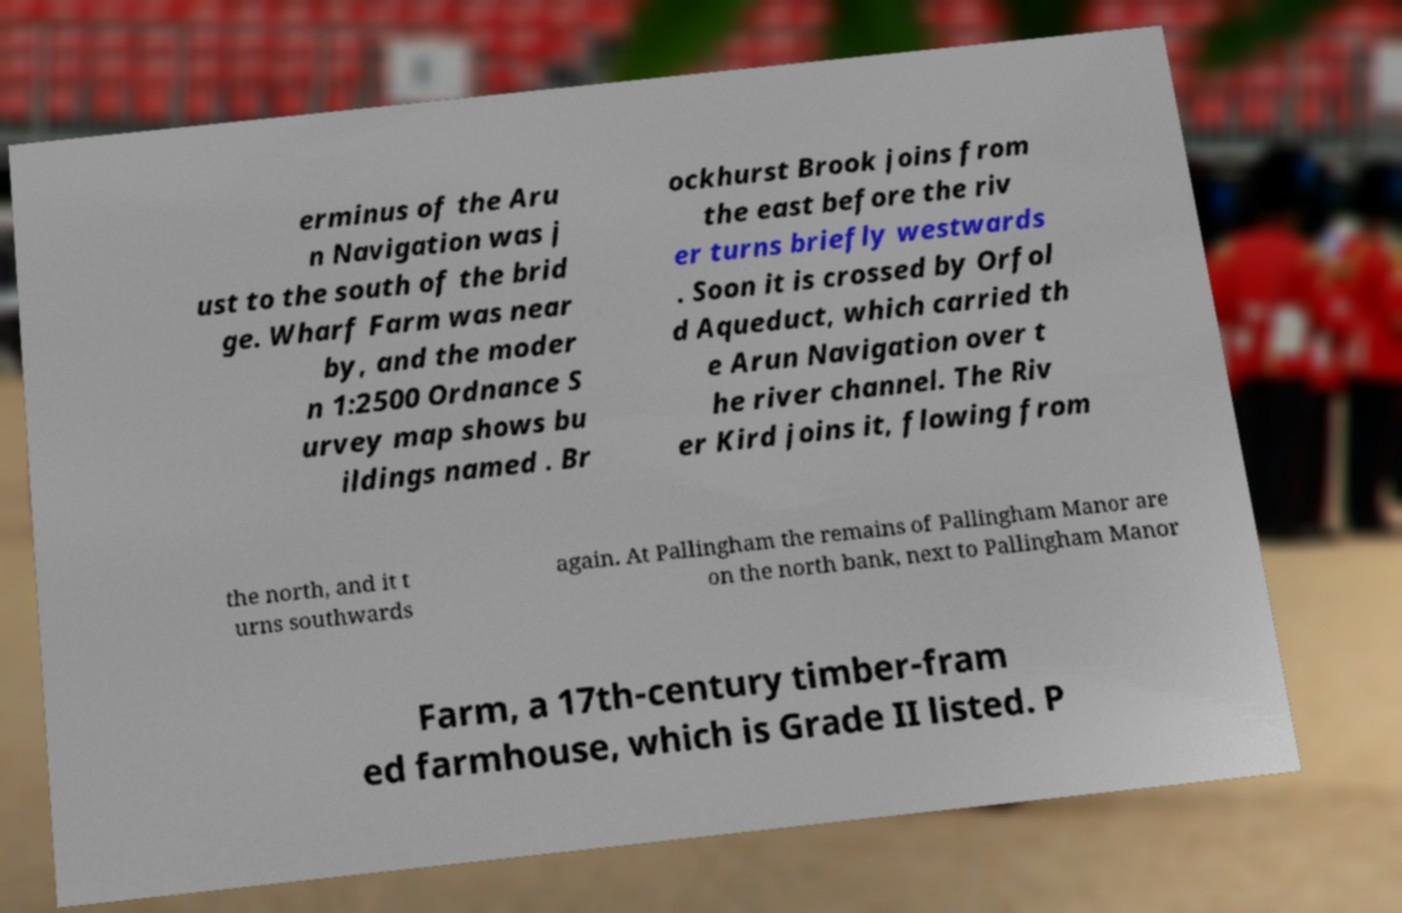For documentation purposes, I need the text within this image transcribed. Could you provide that? erminus of the Aru n Navigation was j ust to the south of the brid ge. Wharf Farm was near by, and the moder n 1:2500 Ordnance S urvey map shows bu ildings named . Br ockhurst Brook joins from the east before the riv er turns briefly westwards . Soon it is crossed by Orfol d Aqueduct, which carried th e Arun Navigation over t he river channel. The Riv er Kird joins it, flowing from the north, and it t urns southwards again. At Pallingham the remains of Pallingham Manor are on the north bank, next to Pallingham Manor Farm, a 17th-century timber-fram ed farmhouse, which is Grade II listed. P 